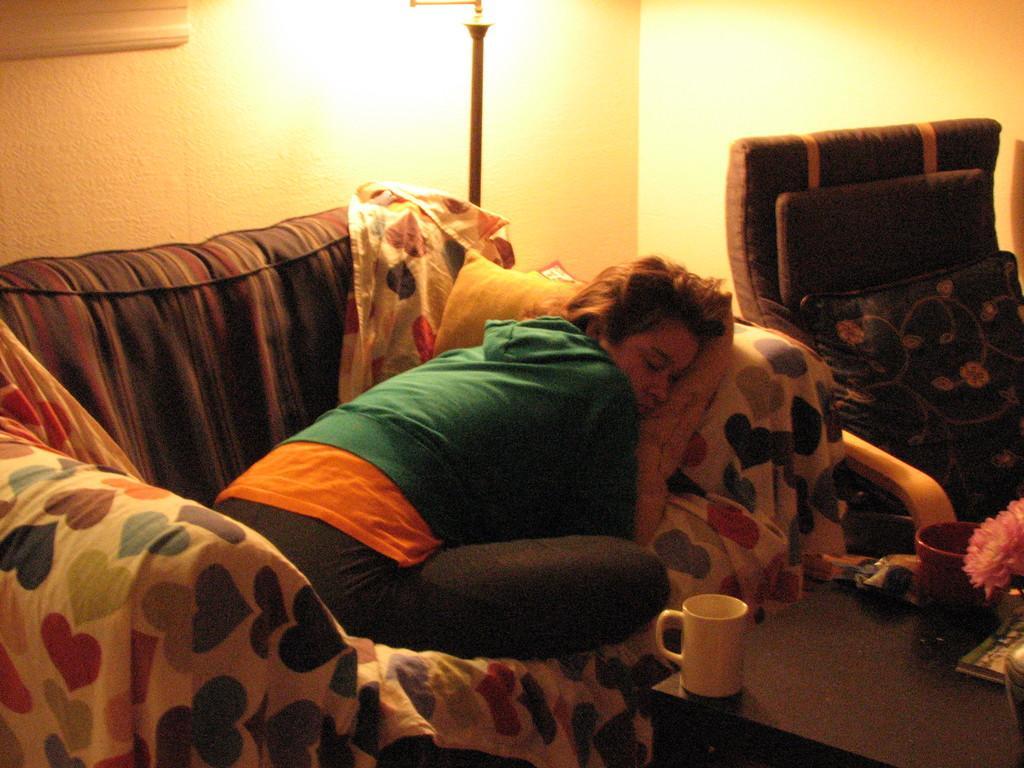Describe this image in one or two sentences. This picture is clicked inside. On the left there is a person seems to be sitting on a couch. On the right we can see a couch and a table on the top of which a cup and some other items are placed. In the background we can see a metal rod and a wall. 